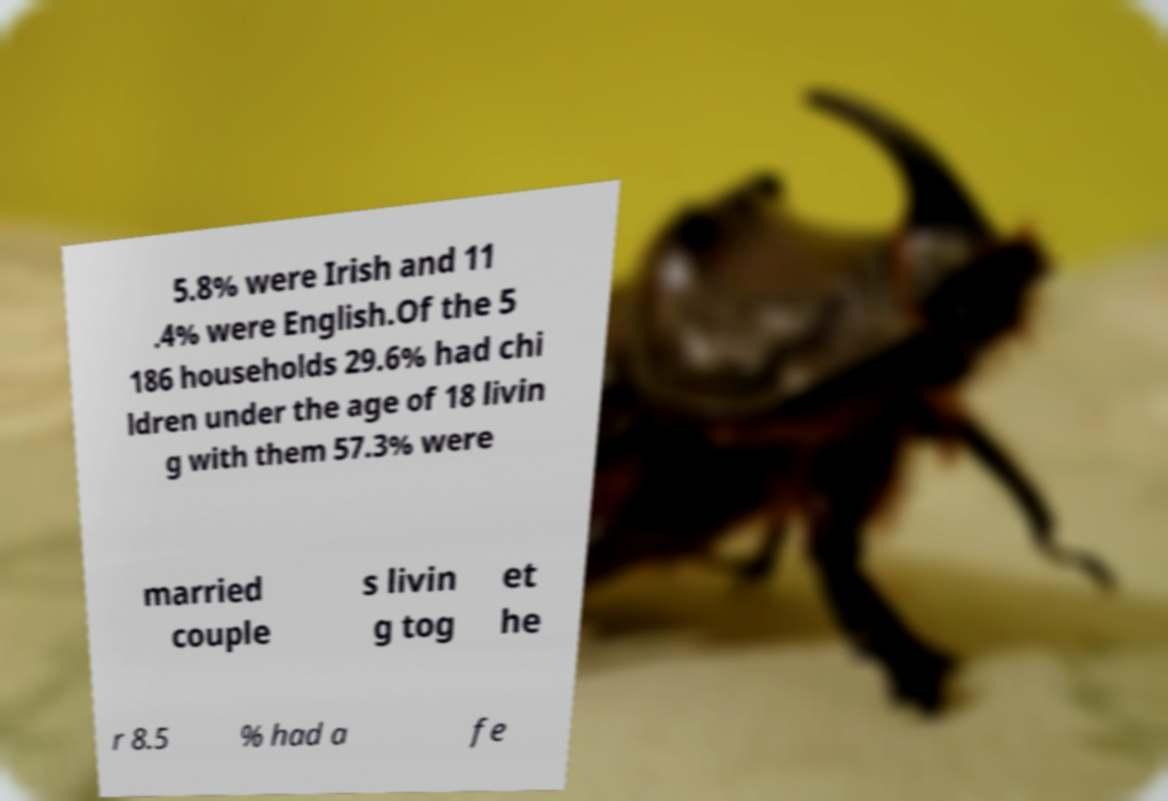Could you extract and type out the text from this image? 5.8% were Irish and 11 .4% were English.Of the 5 186 households 29.6% had chi ldren under the age of 18 livin g with them 57.3% were married couple s livin g tog et he r 8.5 % had a fe 